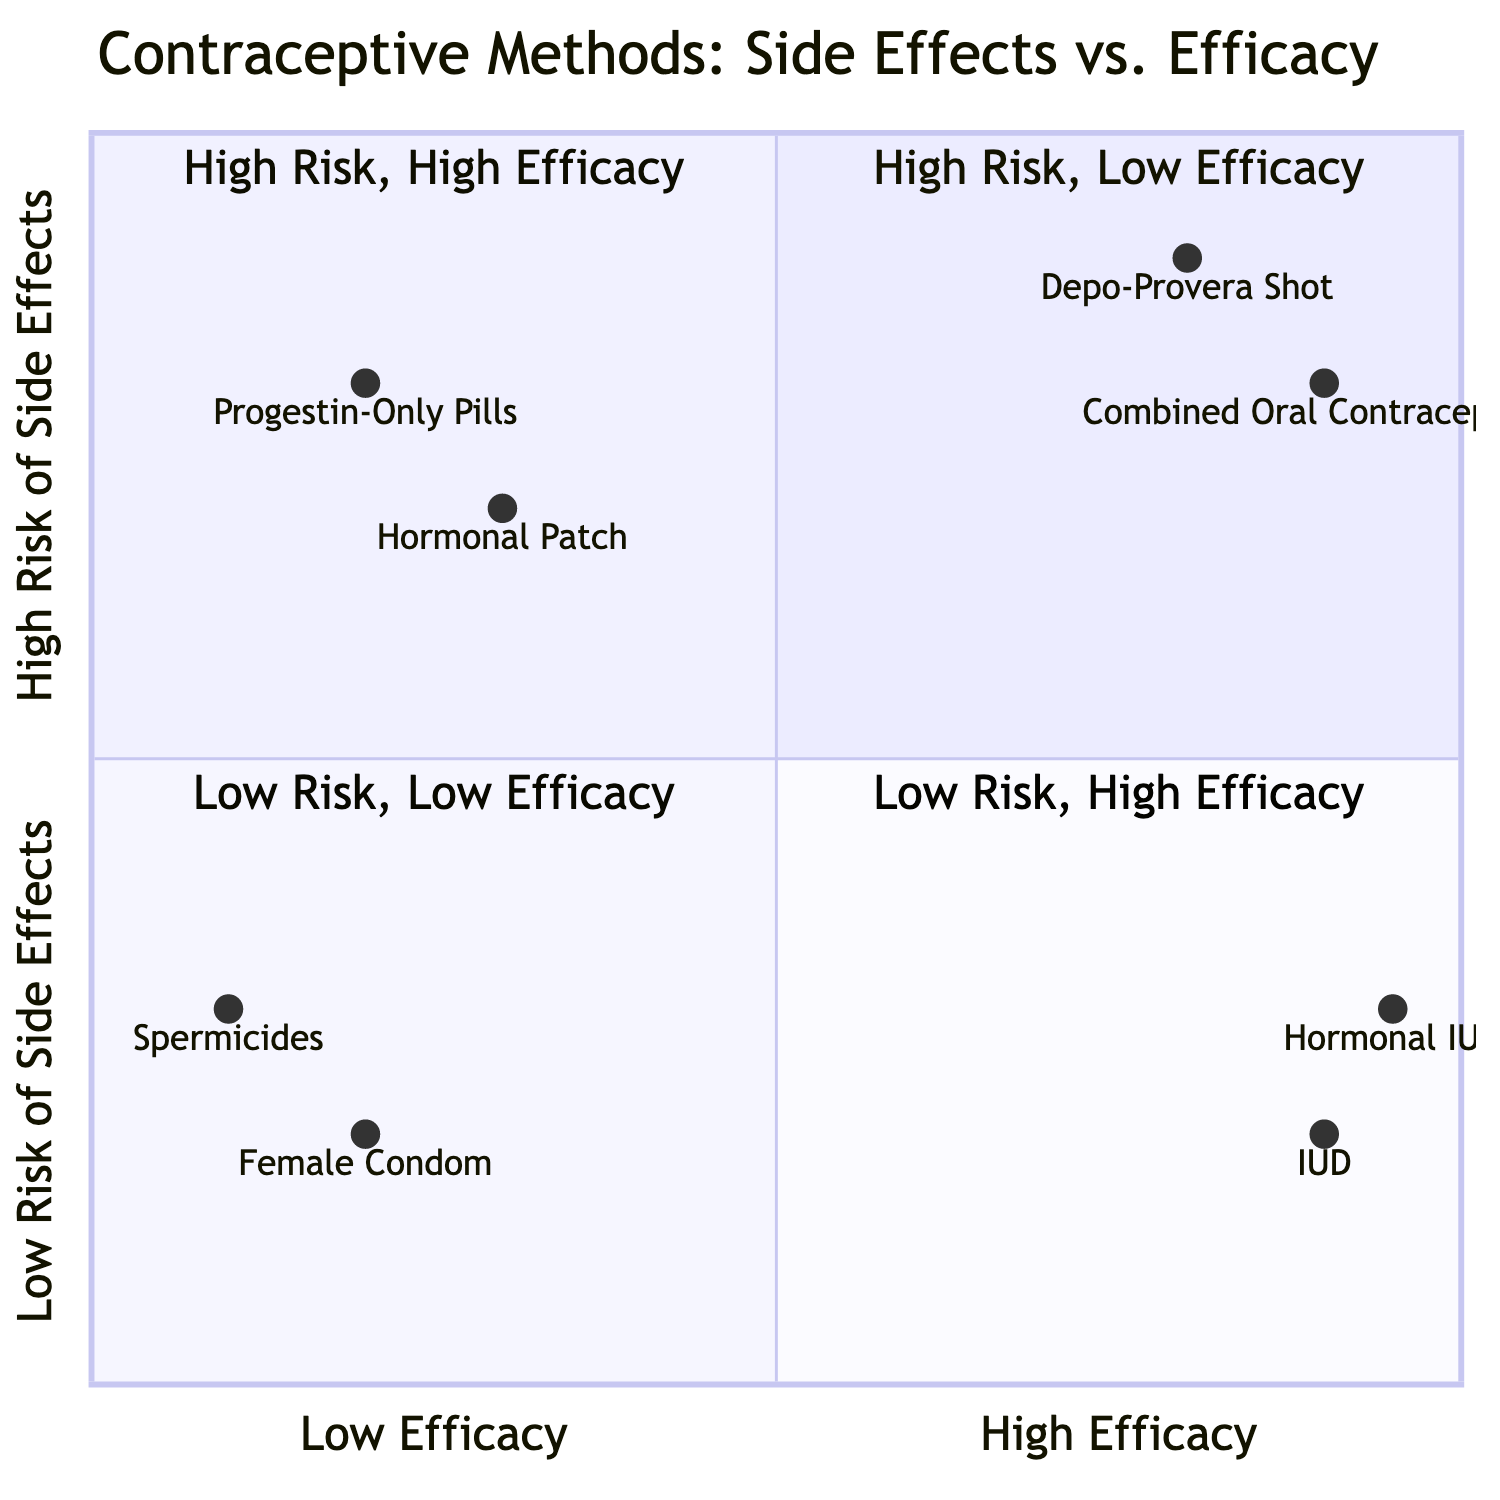What contraceptive method is listed in the "High Risk of Side Effects, Low Efficacy" quadrant? In the "High Risk of Side Effects, Low Efficacy" quadrant, there are two methods listed: "Hormonal Patch" and "Progestin-Only Pills". The first one mentioned is "Hormonal Patch".
Answer: Hormonal Patch How many contraceptive methods have high efficacy and high risk of side effects? The "High Risk of Side Effects, High Efficacy" quadrant contains two methods: "Depo-Provera Shot" and "Combined Oral Contraceptives", resulting in a total of two methods.
Answer: 2 Which patient demographic is associated with the "Combined Oral Contraceptives"? The "Combined Oral Contraceptives" listed in the "High Risk of Side Effects, High Efficacy" quadrant is associated with the patient demographic "Women Over 35 Who Smoke".
Answer: Women Over 35 Who Smoke What is the risk level of side effects for the "Intrauterine Device (IUD)"? The "Intrauterine Device (IUD)" is located in the "Low Risk of Side Effects, High Efficacy" quadrant, indicating that it has a low risk of side effects.
Answer: Low Which contraceptive method has the least risk of side effects? In the "Low Risk of Side Effects, Low Efficacy" quadrant, the "Female Condom" appears first, representing the lowest risk of side effects among the listed methods.
Answer: Female Condom What are the side effects associated with the "Depo-Provera Shot"? The side effects associated with the "Depo-Provera Shot", found in the "High Risk of Side Effects, High Efficacy" quadrant, are "Bone Density Loss" and "Weight Gain".
Answer: Bone Density Loss, Weight Gain How many methods fall under the category of low efficacy? The "Low Efficacy" quadrant contains the following methods: "Hormonal Patch", "Progestin-Only Pills", "Female Condom", and "Spermicides", adding up to a total of four methods.
Answer: 4 Which demographic is linked to the "Hormonal IUD"? The "Hormonal IUD" in the "Low Risk of Side Effects, High Efficacy" quadrant is linked to the demographic "Women Planning Long-Term Birth Control".
Answer: Women Planning Long-Term Birth Control What is the efficacy association of "Spermicides"? "Spermicides" fall into the "Low Risk of Side Effects, Low Efficacy" quadrant, indicating they are associated with low efficacy.
Answer: Low Efficacy 